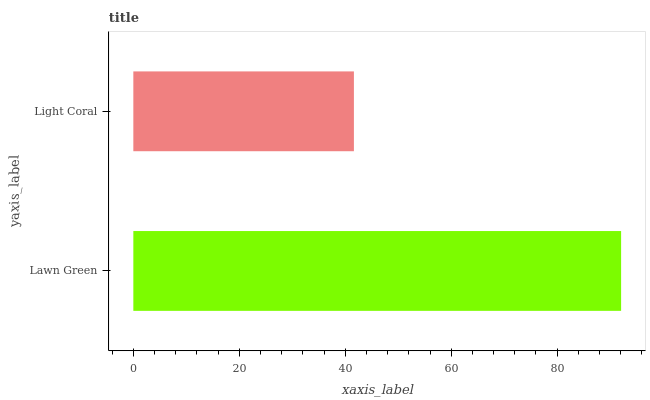Is Light Coral the minimum?
Answer yes or no. Yes. Is Lawn Green the maximum?
Answer yes or no. Yes. Is Light Coral the maximum?
Answer yes or no. No. Is Lawn Green greater than Light Coral?
Answer yes or no. Yes. Is Light Coral less than Lawn Green?
Answer yes or no. Yes. Is Light Coral greater than Lawn Green?
Answer yes or no. No. Is Lawn Green less than Light Coral?
Answer yes or no. No. Is Lawn Green the high median?
Answer yes or no. Yes. Is Light Coral the low median?
Answer yes or no. Yes. Is Light Coral the high median?
Answer yes or no. No. Is Lawn Green the low median?
Answer yes or no. No. 